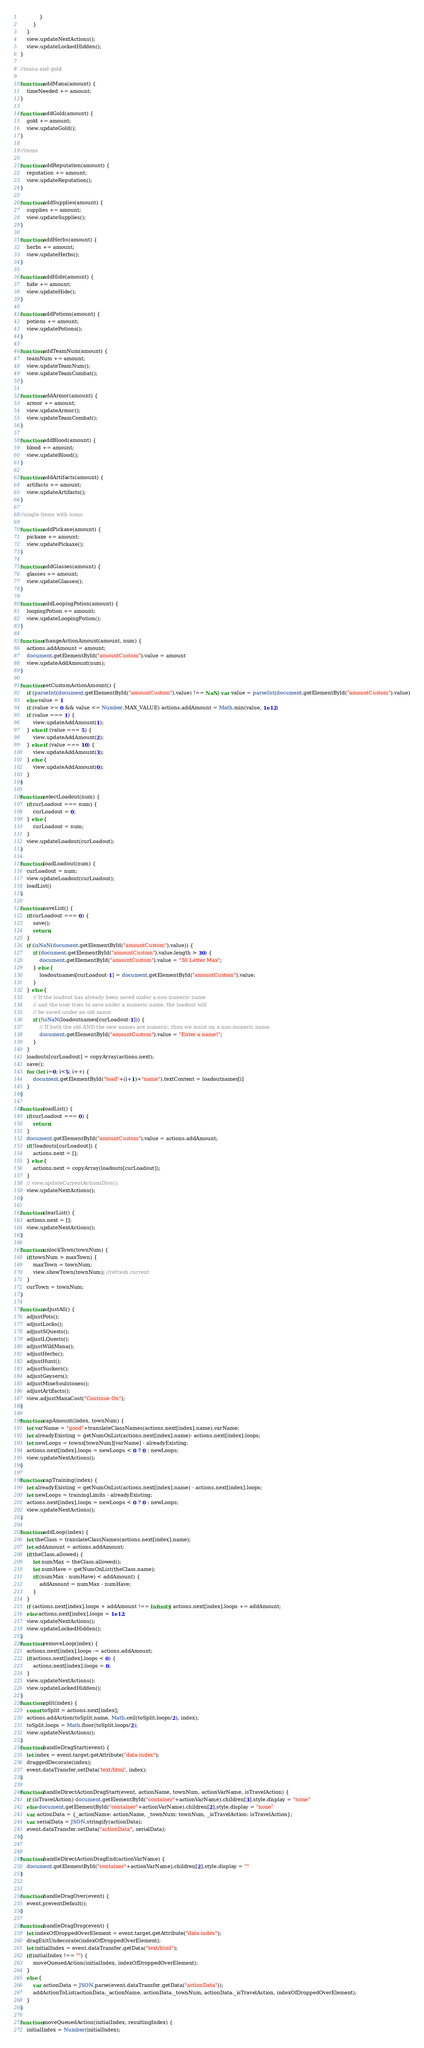Convert code to text. <code><loc_0><loc_0><loc_500><loc_500><_JavaScript_>            }
        }
    }
    view.updateNextActions();
    view.updateLockedHidden();
}

//mana and gold

function addMana(amount) {
    timeNeeded += amount;
}

function addGold(amount) {
    gold += amount;
    view.updateGold();
}

//items

function addReputation(amount) {
    reputation += amount;
    view.updateReputation();
}

function addSupplies(amount) {
    supplies += amount;
    view.updateSupplies();
}

function addHerbs(amount) {
    herbs += amount;
    view.updateHerbs();
}

function addHide(amount) {
    hide += amount;
    view.updateHide();
}

function addPotions(amount) {
    potions += amount;
    view.updatePotions();
}

function addTeamNum(amount) {
    teamNum += amount;
    view.updateTeamNum();
    view.updateTeamCombat();
}

function addArmor(amount) {
    armor += amount;
    view.updateArmor();
    view.updateTeamCombat();
}

function addBlood(amount) {
    blood += amount;
    view.updateBlood();
}

function addArtifacts(amount) {
    artifacts += amount;
    view.updateArtifacts();
}

//single items with icons

function addPickaxe(amount) {
    pickaxe += amount;
    view.updatePickaxe();
}

function addGlasses(amount) {
    glasses += amount;
    view.updateGlasses();
}

function addLoopingPotion(amount) {
    loopingPotion += amount;
    view.updateLoopingPotion();
}

function changeActionAmount(amount, num) {
    actions.addAmount = amount;
    document.getElementById("amountCustom").value = amount
    view.updateAddAmount(num);
}

function setCustomActionAmount() {
    if (parseInt(document.getElementById("amountCustom").value) !== NaN) var value = parseInt(document.getElementById("amountCustom").value)
    else value = 1
    if (value >= 0 && value <= Number.MAX_VALUE) actions.addAmount = Math.min(value, 1e12)
    if (value === 1) {
        view.updateAddAmount(1);
    } else if (value === 5) {
        view.updateAddAmount(2);
    } else if (value === 10) {
        view.updateAddAmount(3);
    } else {
        view.updateAddAmount(0);
    }
}

function selectLoadout(num) {
    if(curLoadout === num) {
        curLoadout = 0;
    } else {
        curLoadout = num;
    }
    view.updateLoadout(curLoadout);
}

function loadLoadout(num) {
    curLoadout = num;
    view.updateLoadout(curLoadout);
    loadList()
}

function saveList() {
    if(curLoadout === 0) {
        save();
        return;
    }
    if (isNaN(document.getElementById("amountCustom").value)) {
        if (document.getElementById("amountCustom").value.length > 30) {
            document.getElementById("amountCustom").value = "30 Letter Max";
        } else {
            loadoutnames[curLoadout-1] = document.getElementById("amountCustom").value;
        }
    } else {
        // If the loadout has already been saved under a non-numeric name
        // and the user tries to save under a numeric name, the loadout will
        // be saved under an old name.
        if (!isNaN(loadoutnames[curLoadout-1])) {
            // If both the old AND the new names are numeric, then we insist on a non-numeric name.
            document.getElementById("amountCustom").value = "Enter a name!";
        }
    }
    loadouts[curLoadout] = copyArray(actions.next);
    save();
    for (let i=0; i<5; i++) {
        document.getElementById("load"+(i+1)+"name").textContent = loadoutnames[i]
    }
}

function loadList() {
    if(curLoadout === 0) {
        return;
    }
    document.getElementById("amountCustom").value = actions.addAmount;
    if(!loadouts[curLoadout]) {
        actions.next = [];
    } else {
        actions.next = copyArray(loadouts[curLoadout]);
    }
    // view.updateCurrentActionsDivs();
    view.updateNextActions();
}

function clearList() {
    actions.next = [];
    view.updateNextActions();
}

function unlockTown(townNum) {
    if(townNum > maxTown) {
        maxTown = townNum;
        view.showTown(townNum); //refresh current
    }
    curTown = townNum;
}

function adjustAll() {
    adjustPots();
    adjustLocks();
    adjustSQuests();
    adjustLQuests();
    adjustWildMana();
    adjustHerbs();
    adjustHunt();
    adjustSuckers();
    adjustGeysers();
    adjustMineSoulstones();
    adjustArtifacts();
    view.adjustManaCost("Continue On");
}

function capAmount(index, townNum) {
    let varName = "good"+translateClassNames(actions.next[index].name).varName;
    let alreadyExisting = getNumOnList(actions.next[index].name)- actions.next[index].loops;
    let newLoops = towns[townNum][varName] - alreadyExisting;
    actions.next[index].loops = newLoops < 0 ? 0 : newLoops;
    view.updateNextActions();
}

function capTraining(index) {
    let alreadyExisting = getNumOnList(actions.next[index].name) - actions.next[index].loops;
    let newLoops = trainingLimits - alreadyExisting;
    actions.next[index].loops = newLoops < 0 ? 0 : newLoops;
    view.updateNextActions();
}

function addLoop(index) {
    let theClass = translateClassNames(actions.next[index].name);
    let addAmount = actions.addAmount;
    if(theClass.allowed) {
        let numMax = theClass.allowed();
        let numHave = getNumOnList(theClass.name);
        if((numMax - numHave) < addAmount) {
            addAmount = numMax - numHave;
        }
    }
    if (actions.next[index].loops + addAmount !== Infinity) actions.next[index].loops += addAmount;
    else actions.next[index].loops = 1e12;
    view.updateNextActions();
    view.updateLockedHidden();
}
function removeLoop(index) {
    actions.next[index].loops -= actions.addAmount;
    if(actions.next[index].loops < 0) {
        actions.next[index].loops = 0;
    }
    view.updateNextActions();
    view.updateLockedHidden();
}
function split(index) {
    const toSplit = actions.next[index];
    actions.addAction(toSplit.name, Math.ceil(toSplit.loops/2), index);
    toSplit.loops = Math.floor(toSplit.loops/2);
    view.updateNextActions();
}
function handleDragStart(event) {
    let index = event.target.getAttribute("data-index");
    draggedDecorate(index);
    event.dataTransfer.setData('text/html', index);
}

function handleDirectActionDragStart(event, actionName, townNum, actionVarName, isTravelAction) {
    if (isTravelAction) document.getElementById("container"+actionVarName).children[3].style.display = "none"
    else document.getElementById("container"+actionVarName).children[2].style.display = "none"
    var actionData = {_actionName: actionName, _townNum: townNum, _isTravelAction: isTravelAction};
    var serialData = JSON.stringify(actionData);
    event.dataTransfer.setData("actionData", serialData);
}


function handleDirectActionDragEnd(actionVarName) {
    document.getElementById("container"+actionVarName).children[2].style.display = ""
}


function handleDragOver(event) {
    event.preventDefault();
}

function handleDragDrop(event) {
    let indexOfDroppedOverElement = event.target.getAttribute("data-index");
    dragExitUndecorate(indexOfDroppedOverElement);
    let initialIndex = event.dataTransfer.getData("text/html");
    if(initialIndex !== "") {
        moveQueuedAction(initialIndex, indexOfDroppedOverElement);
    }
    else {
        var actionData = JSON.parse(event.dataTransfer.getData("actionData"));
        addActionToList(actionData._actionName, actionData._townNum, actionData._isTravelAction, indexOfDroppedOverElement);
    }
}

function moveQueuedAction(initialIndex, resultingIndex) {
    initialIndex = Number(initialIndex);</code> 